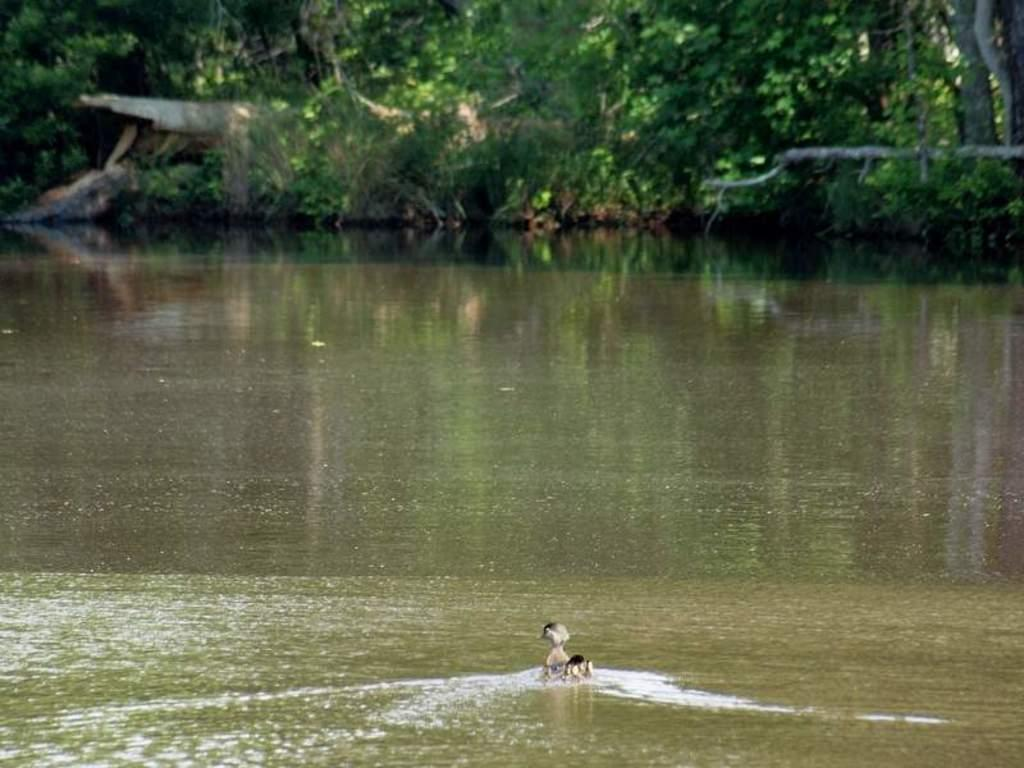What animal can be seen in the image? There is a bird in the image. What is the bird doing in the image? The bird is swimming in the water. What body of water is present in the image? There is a lake in the image. What can be seen in the background of the image? There are trees in the background of the image. What type of joke is the bird telling in the image? There is no indication in the image that the bird is telling a joke, as birds do not have the ability to communicate through jokes. 